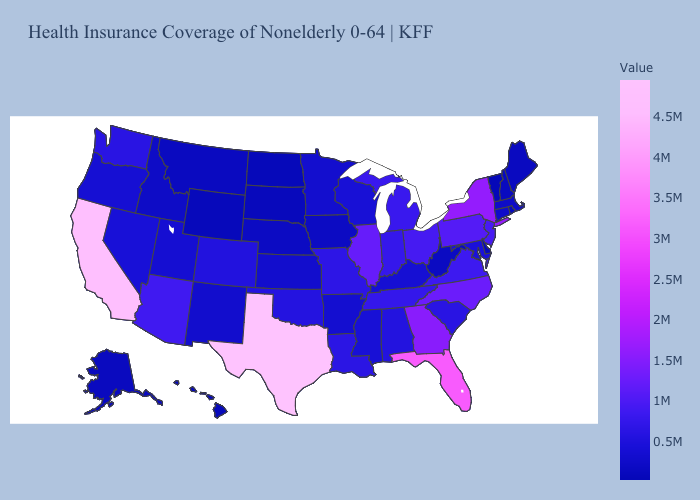Among the states that border Texas , does New Mexico have the highest value?
Be succinct. No. Which states have the highest value in the USA?
Concise answer only. Texas. Which states have the lowest value in the South?
Write a very short answer. Delaware. Does West Virginia have the highest value in the South?
Keep it brief. No. Among the states that border California , which have the lowest value?
Quick response, please. Oregon. Among the states that border South Dakota , does Montana have the lowest value?
Give a very brief answer. No. 